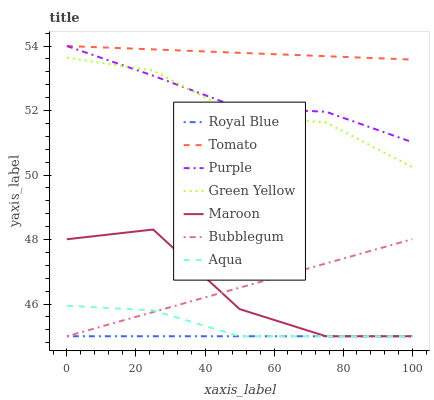Does Royal Blue have the minimum area under the curve?
Answer yes or no. Yes. Does Tomato have the maximum area under the curve?
Answer yes or no. Yes. Does Purple have the minimum area under the curve?
Answer yes or no. No. Does Purple have the maximum area under the curve?
Answer yes or no. No. Is Bubblegum the smoothest?
Answer yes or no. Yes. Is Maroon the roughest?
Answer yes or no. Yes. Is Purple the smoothest?
Answer yes or no. No. Is Purple the roughest?
Answer yes or no. No. Does Aqua have the lowest value?
Answer yes or no. Yes. Does Purple have the lowest value?
Answer yes or no. No. Does Purple have the highest value?
Answer yes or no. Yes. Does Aqua have the highest value?
Answer yes or no. No. Is Royal Blue less than Tomato?
Answer yes or no. Yes. Is Tomato greater than Maroon?
Answer yes or no. Yes. Does Royal Blue intersect Bubblegum?
Answer yes or no. Yes. Is Royal Blue less than Bubblegum?
Answer yes or no. No. Is Royal Blue greater than Bubblegum?
Answer yes or no. No. Does Royal Blue intersect Tomato?
Answer yes or no. No. 